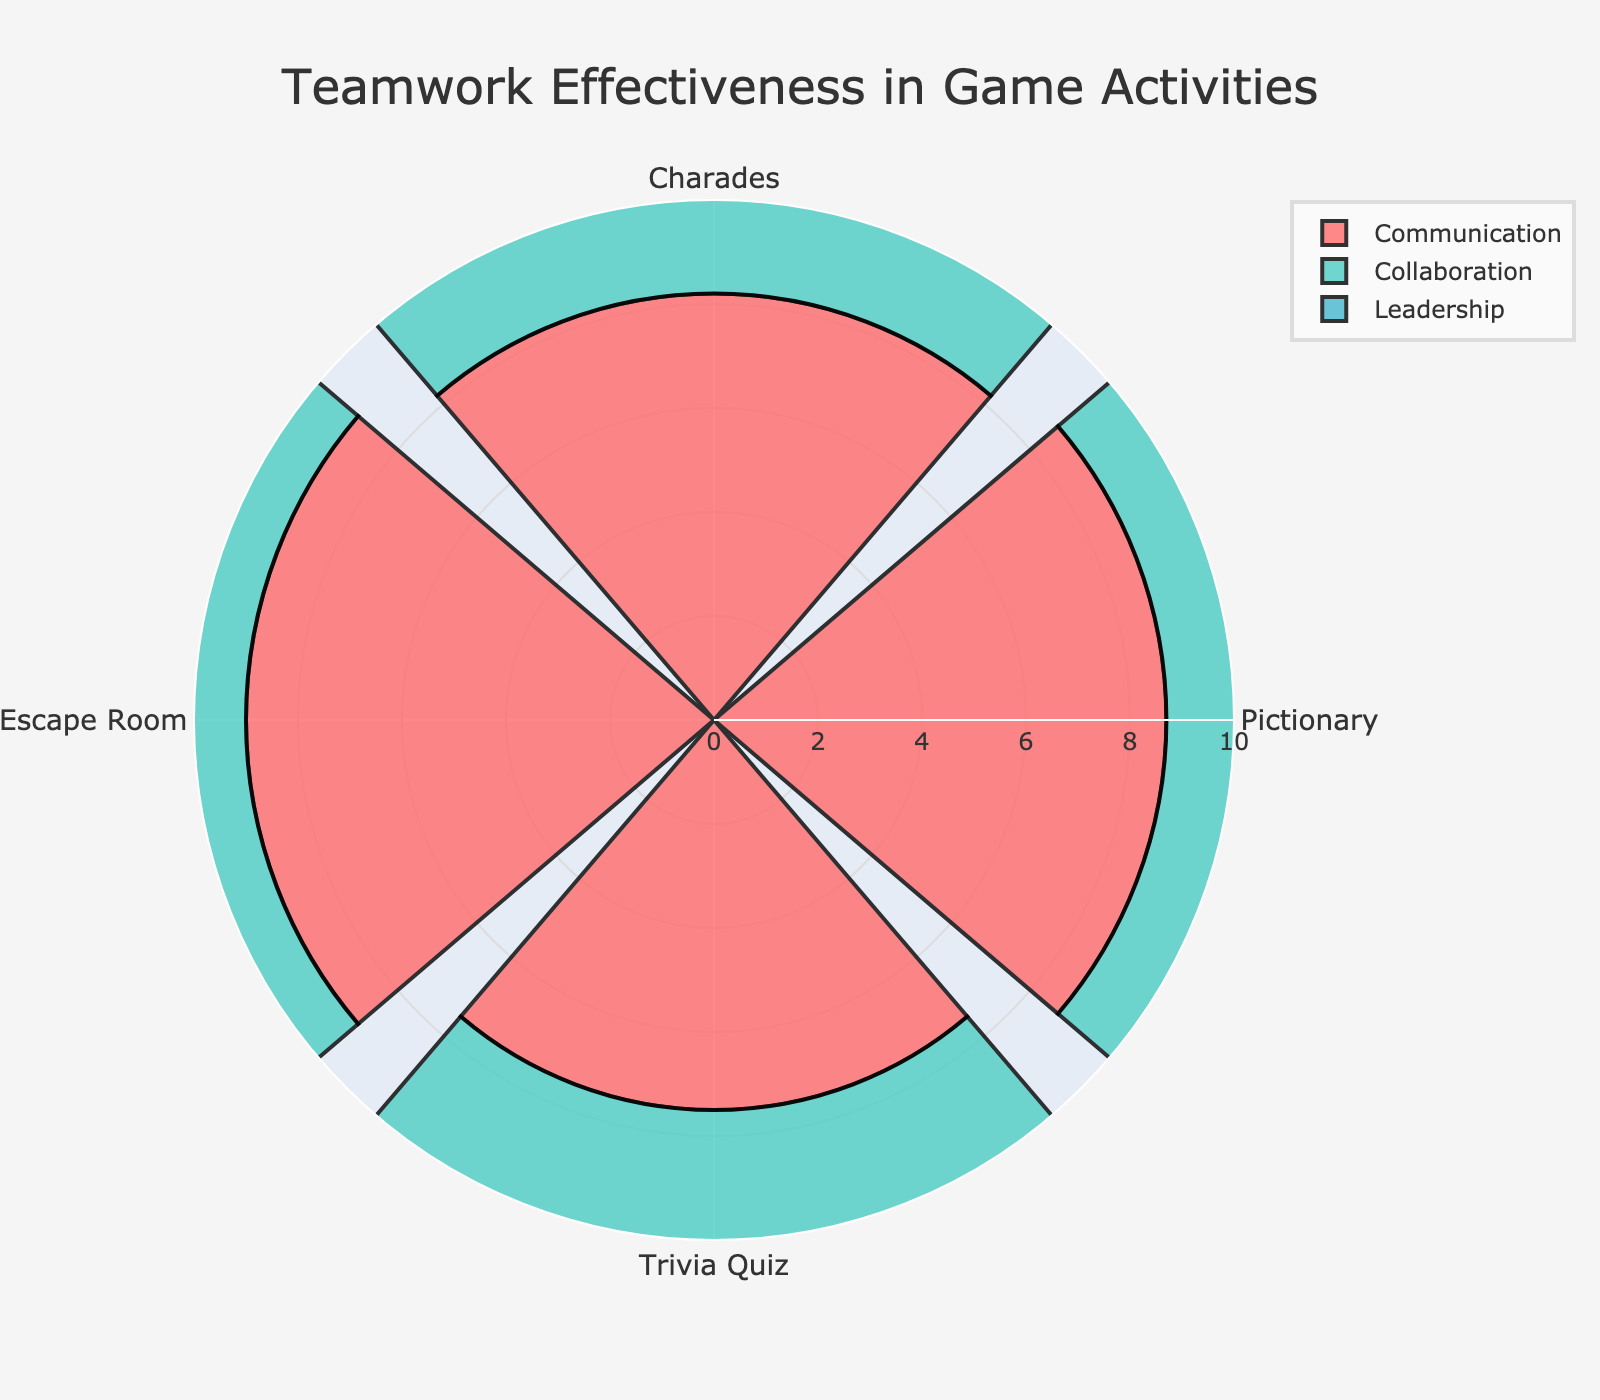What is the title of the figure? The title of the figure is located at the top and provides the main focus of the visual representation.
Answer: Teamwork Effectiveness in Game Activities How many game activities are represented in the figure? The angular axis shows the labels for each game activity, allowing us to count them.
Answer: Four Which game activity received the highest average score across all three categories? To find the average, sum the scores for each category and divide by the total number of categories for each game. Charades: (8.2 + 7.5 + 6.8) / 3 = 7.5. Pictionary: (8.7 + 8.1 + 7.0) / 3 = 7.93. Trivia Quiz: (7.5 + 7.2 + 6.5) / 3 = 7.07. Escape Room: (9.0 + 8.9 + 8.5) / 3 = 8.8. Escape Room has the highest average score.
Answer: Escape Room Which category has the most consistent scores across all activities? Comparing the variance within each category across the activities helps determine consistency. Communication: 8.2, 8.7, 7.5, 9.0 (range = 1.5). Collaboration: 7.5, 8.1, 7.2, 8.9 (range = 1.7). Leadership: 6.8, 7.0, 6.5, 8.5 (range = 2.0). Communication has the smallest range and hence is the most consistent.
Answer: Communication Which game activity has the lowest score for Leadership? Review the leadership scores for each activity: Charades: 6.8, Pictionary: 7.0, Trivia Quiz: 6.5, Escape Room: 8.5. Trivia Quiz has the lowest score for Leadership.
Answer: Trivia Quiz What is the difference between the highest and lowest scores for Collaboration? Identify the highest and lowest scores in the Collaboration category: highest is Escape Room with 8.9, and lowest is Trivia Quiz with 7.2. The difference is 8.9 - 7.2 = 1.7.
Answer: 1.7 Which category had the highest score for Pictionary? Compare the scores for Pictionary across all categories: Communication: 8.7, Collaboration: 8.1, Leadership: 7.0. The highest score is in Communication.
Answer: Communication In which activity does Leadership outperform Communication? Compare Communication vs. Leadership scores for all activities: Charades (8.2 vs. 6.8), Pictionary (8.7 vs. 7.0), Trivia Quiz (7.5 vs. 6.5), Escape Room (9.0 vs. 8.5). In none of the activities does Leadership outperform Communication.
Answer: None 